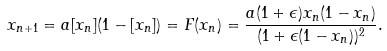<formula> <loc_0><loc_0><loc_500><loc_500>x _ { n + 1 } = a [ x _ { n } ] ( 1 - [ x _ { n } ] ) = F ( x _ { n } ) = \frac { a ( 1 + \epsilon ) x _ { n } ( 1 - x _ { n } ) } { ( 1 + \epsilon ( 1 - x _ { n } ) ) ^ { 2 } } .</formula> 